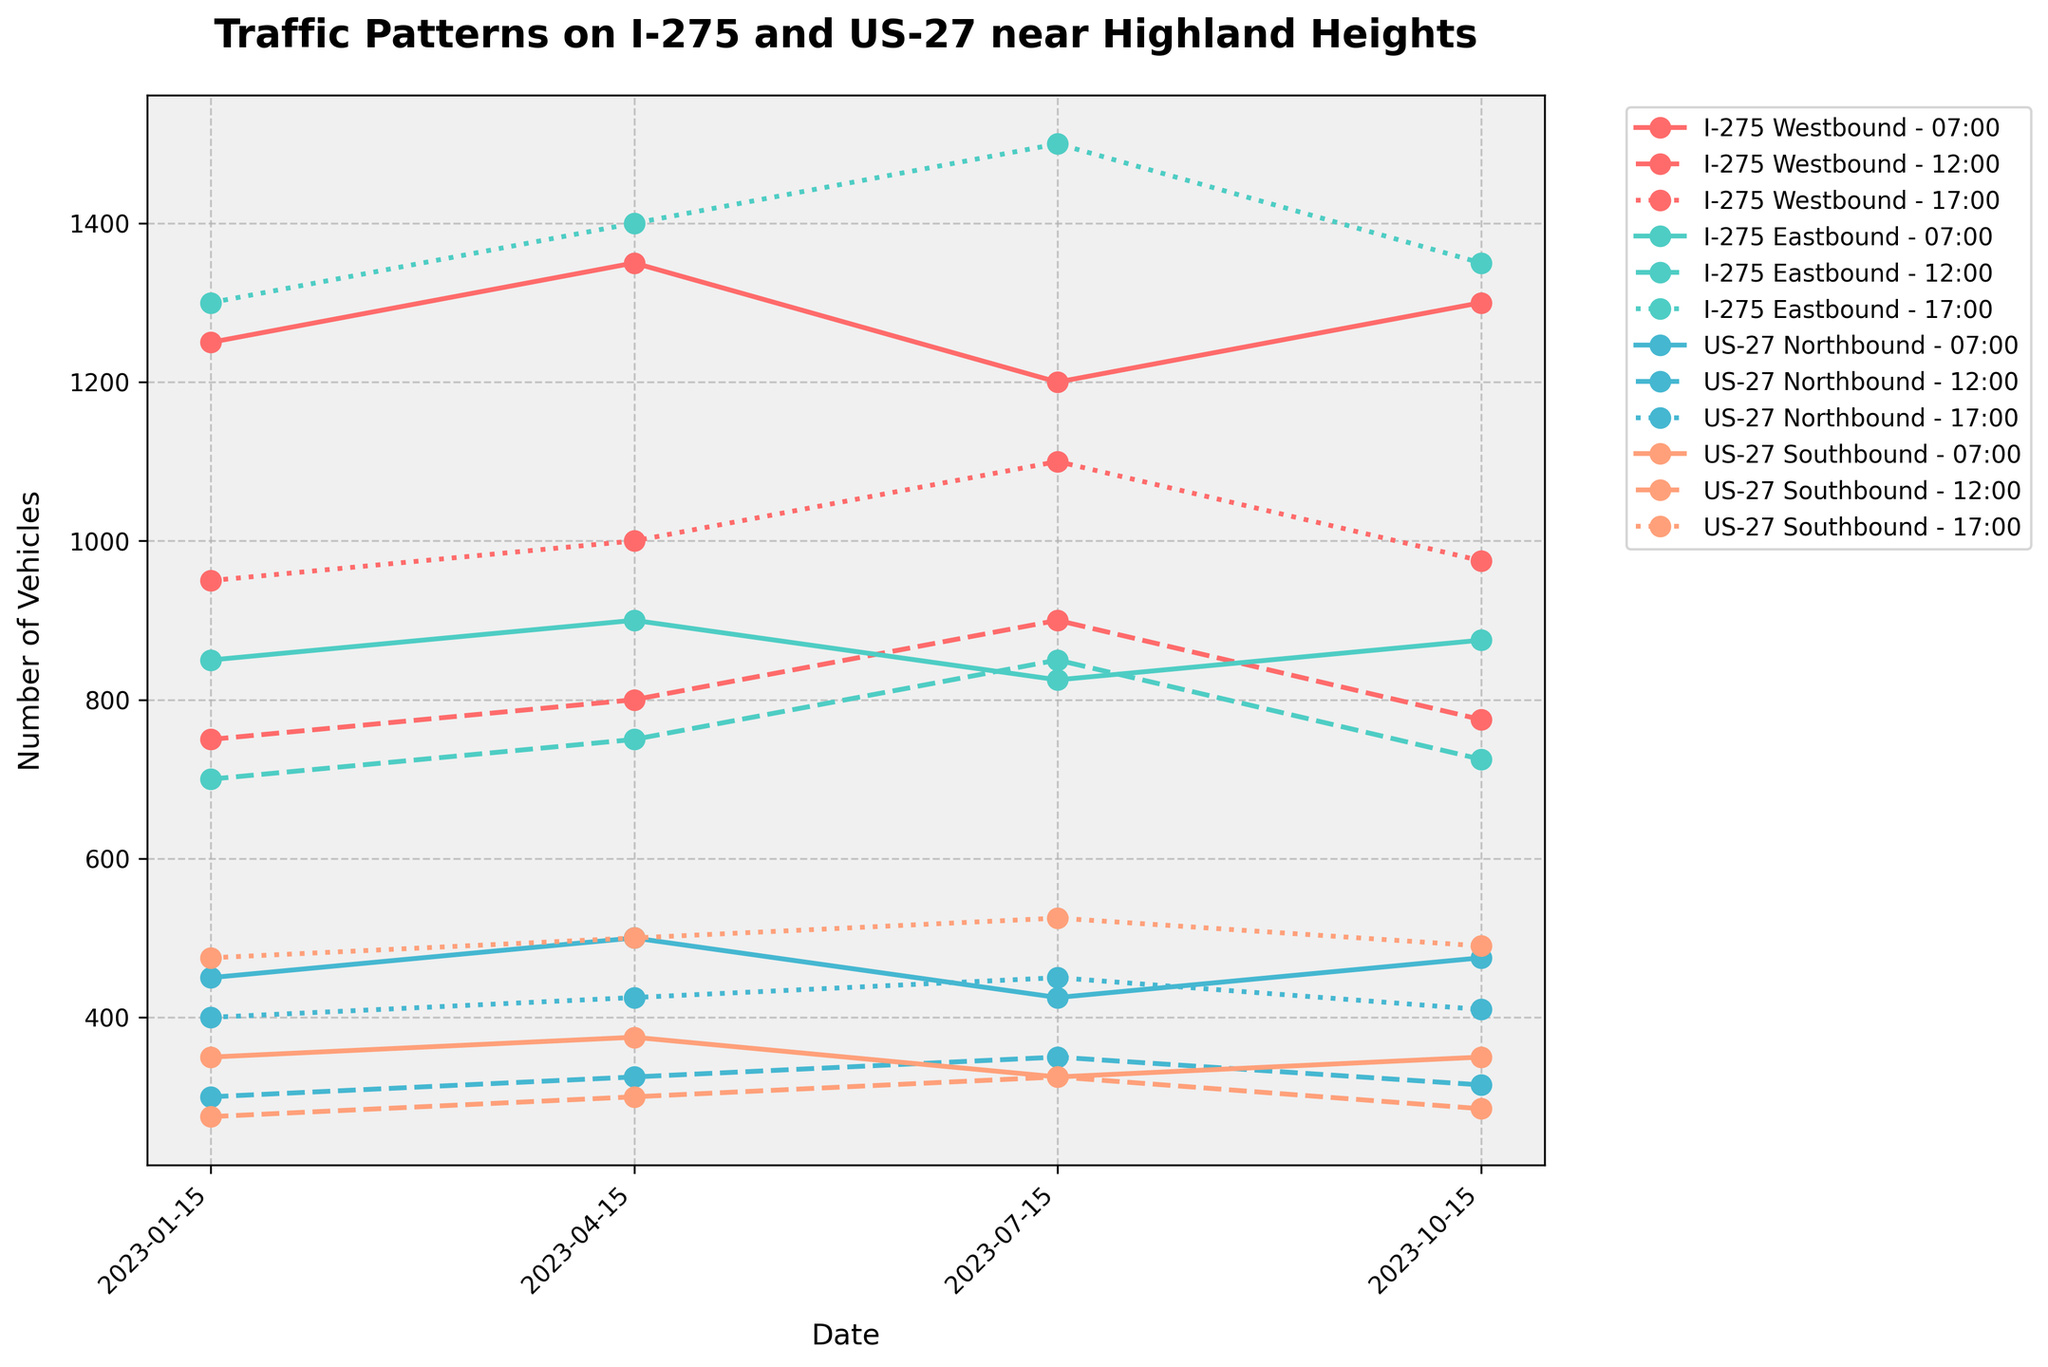What's the peak hour for traffic on I-275 Westbound in July? To determine the peak hour for traffic on I-275 Westbound in July, observe the values for the three different times (7:00, 12:00, 17:00) on July 15th. The values are 1200, 900, and 1100 respectively. The highest value among these is 1200 at 7:00.
Answer: 7:00 Which direction on US-27 shows the greatest increase in traffic from January to April at 17:00? For 17:00 in January, the traffic numbers on US-27 Northbound and Southbound are 400 and 475 respectively. In April, these numbers are 425 and 500. The increase for Northbound is 425 - 400 = 25, and for Southbound is 500 - 475 = 25. Both directions show an equal increase of 25 vehicles.
Answer: Both directions show the same increase What time of day generally shows the highest traffic on I-275 Eastbound across all months? Check the traffic counts for I-275 Eastbound at 07:00, 12:00, and 17:00 across all the months. For January: 07:00 - 850, 12:00 - 700, 17:00 - 1300; April: 07:00 - 900, 12:00 - 750, 17:00 - 1400; July: 07:00 - 825, 12:00 - 850, 17:00 - 1500; October: 07:00 - 875, 12:00 - 725, 17:00 - 1350. The highest value generally appears at 17:00.
Answer: 17:00 Between I-275 Westbound and US-27 Northbound, during which month and time is the difference largest? Calculate the differences between I-275 Westbound and US-27 Northbound for each combination of month and time. 
January: 07:00 - 1250 - 450 = 800, 12:00 - 750 - 300 = 450, 17:00 - 950 - 400 = 550
April: 07:00 - 1350 - 500 = 850, 12:00 - 800 - 325 = 475, 17:00 - 1000 - 425 = 575
July: 07:00 - 1200 - 425 = 775, 12:00 - 900 - 350 = 550, 17:00 - 1100 - 450 = 650
October: 07:00 - 1300 - 475 = 825, 12:00 - 775 - 315 = 460, 17:00 - 975 - 410 = 565
The largest difference is 850 in April at 07:00.
Answer: April at 07:00 Which month has the lowest average traffic on US-27 Southbound at 12:00? Calculate the average traffic at 12:00 for US-27 Southbound in each month. 
January: 275, April: 300, July: 325, October: 285. Sum and average each: 
January: 275, 
April: 300, 
July: 325, 
October: 285. The lowest average traffic occurs in January.
Answer: January How does the traffic on I-275 Eastbound at 17:00 change from April to October? Look at the values for I-275 Eastbound at 17:00 in April and October, which are 1400 and 1350 respectively. Calculate the change: 1350 - 1400 = -50 (a decrease of 50 vehicles).
Answer: Decreases by 50 vehicles Which road-direction combination has the highest traffic in October at any time of day? Examine the traffic counts for October across all times for each road and direction. The highest individual traffic count is I-275 Eastbound at 17:00 with 1350 vehicles.
Answer: I-275 Eastbound at 17:00 Is the traffic at 12:00 higher on I-275 Eastbound or US-27 Northbound in July? Compare the values for both directions at 12:00 in July. I-275 Eastbound: 850, US-27 Northbound: 350. I-275 Eastbound has higher traffic.
Answer: I-275 Eastbound What is the visual trend in traffic patterns for US-27 Northbound from January to October at 7:00? Observe the plotted values for US-27 Northbound at 7:00 across the months. The values are 450 (January), 500 (April), 425 (July), 475 (October). The visual trend shows a fluctuation, with an initial increase from January to April, a drop in July, and a minor increase again in October.
Answer: Fluctuating trend 